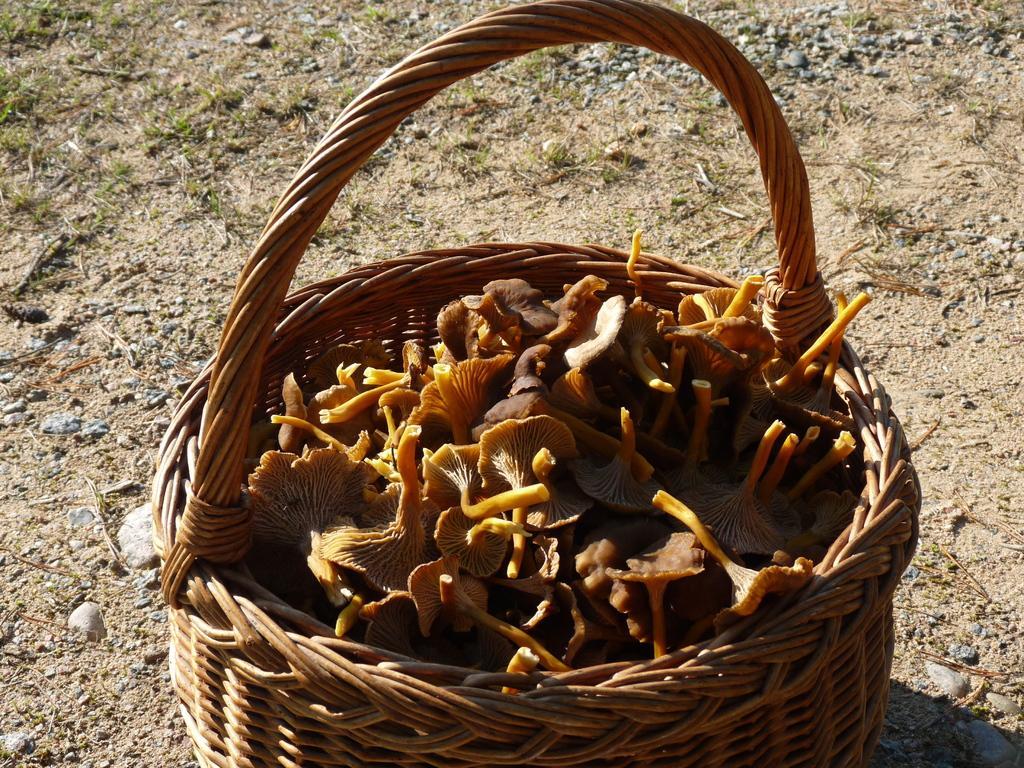How would you summarize this image in a sentence or two? In this picture those are looking like flowers in the basket and I can see grass on the ground. 